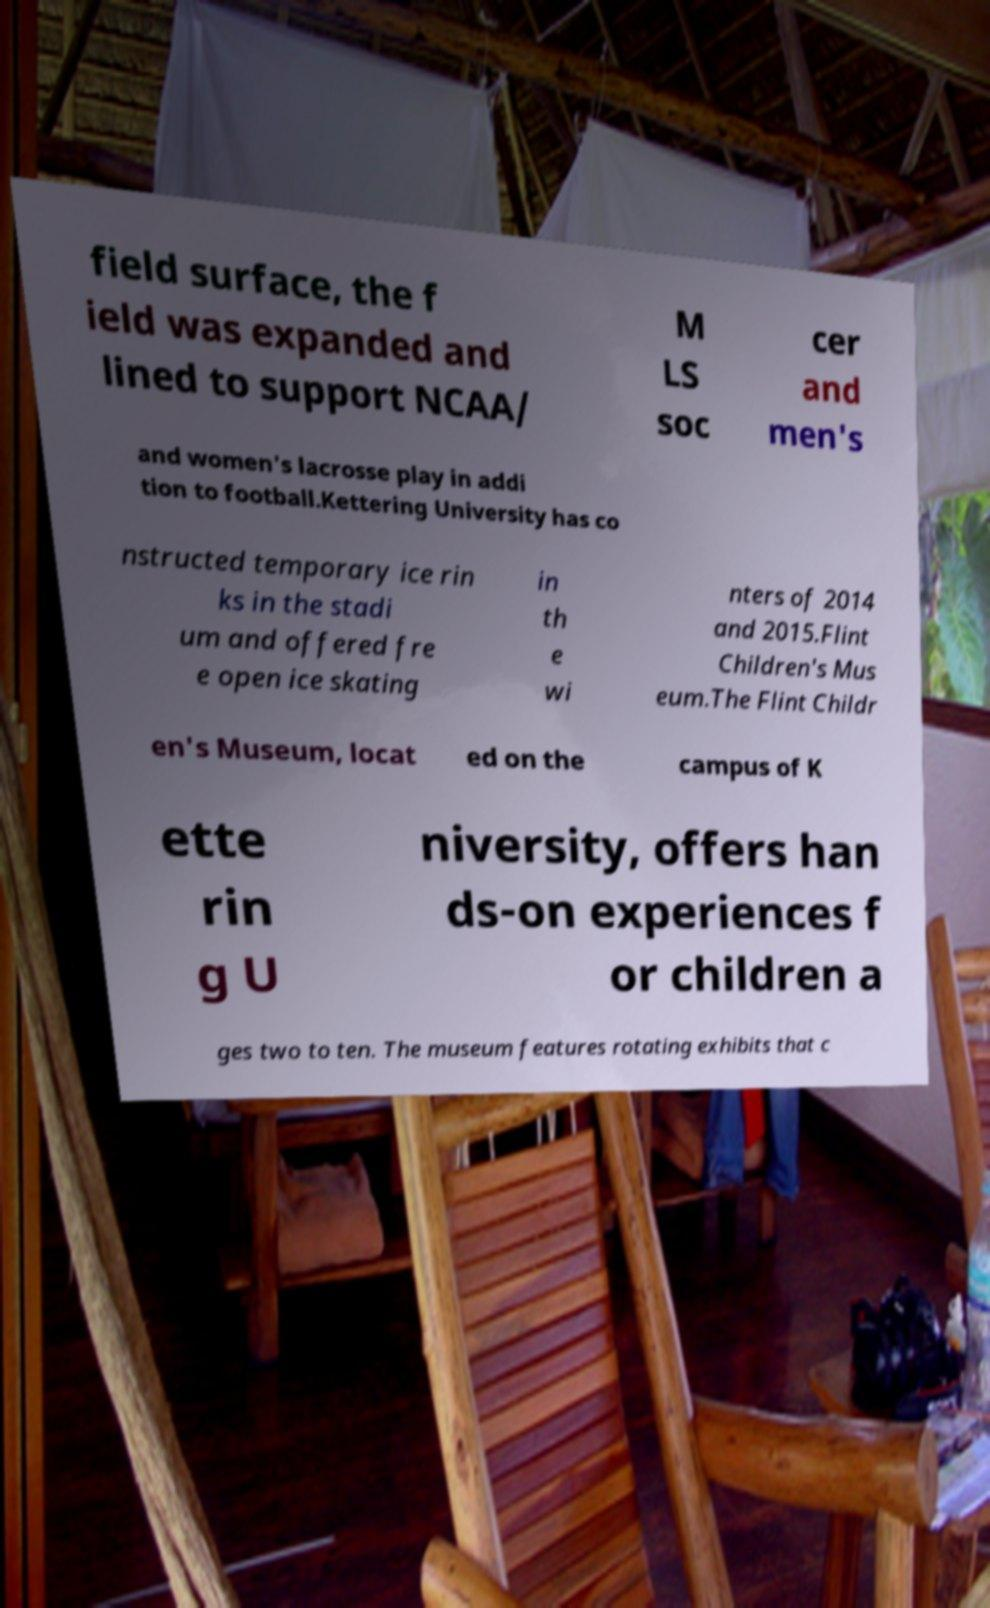Can you accurately transcribe the text from the provided image for me? field surface, the f ield was expanded and lined to support NCAA/ M LS soc cer and men's and women's lacrosse play in addi tion to football.Kettering University has co nstructed temporary ice rin ks in the stadi um and offered fre e open ice skating in th e wi nters of 2014 and 2015.Flint Children's Mus eum.The Flint Childr en's Museum, locat ed on the campus of K ette rin g U niversity, offers han ds-on experiences f or children a ges two to ten. The museum features rotating exhibits that c 